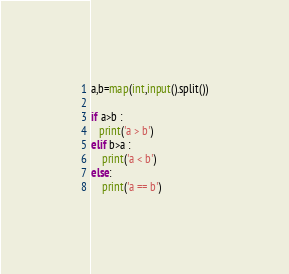<code> <loc_0><loc_0><loc_500><loc_500><_Python_>a,b=map(int,input().split())

if a>b :
   print('a > b')
elif b>a :
    print('a < b')
else:
    print('a == b')
</code> 